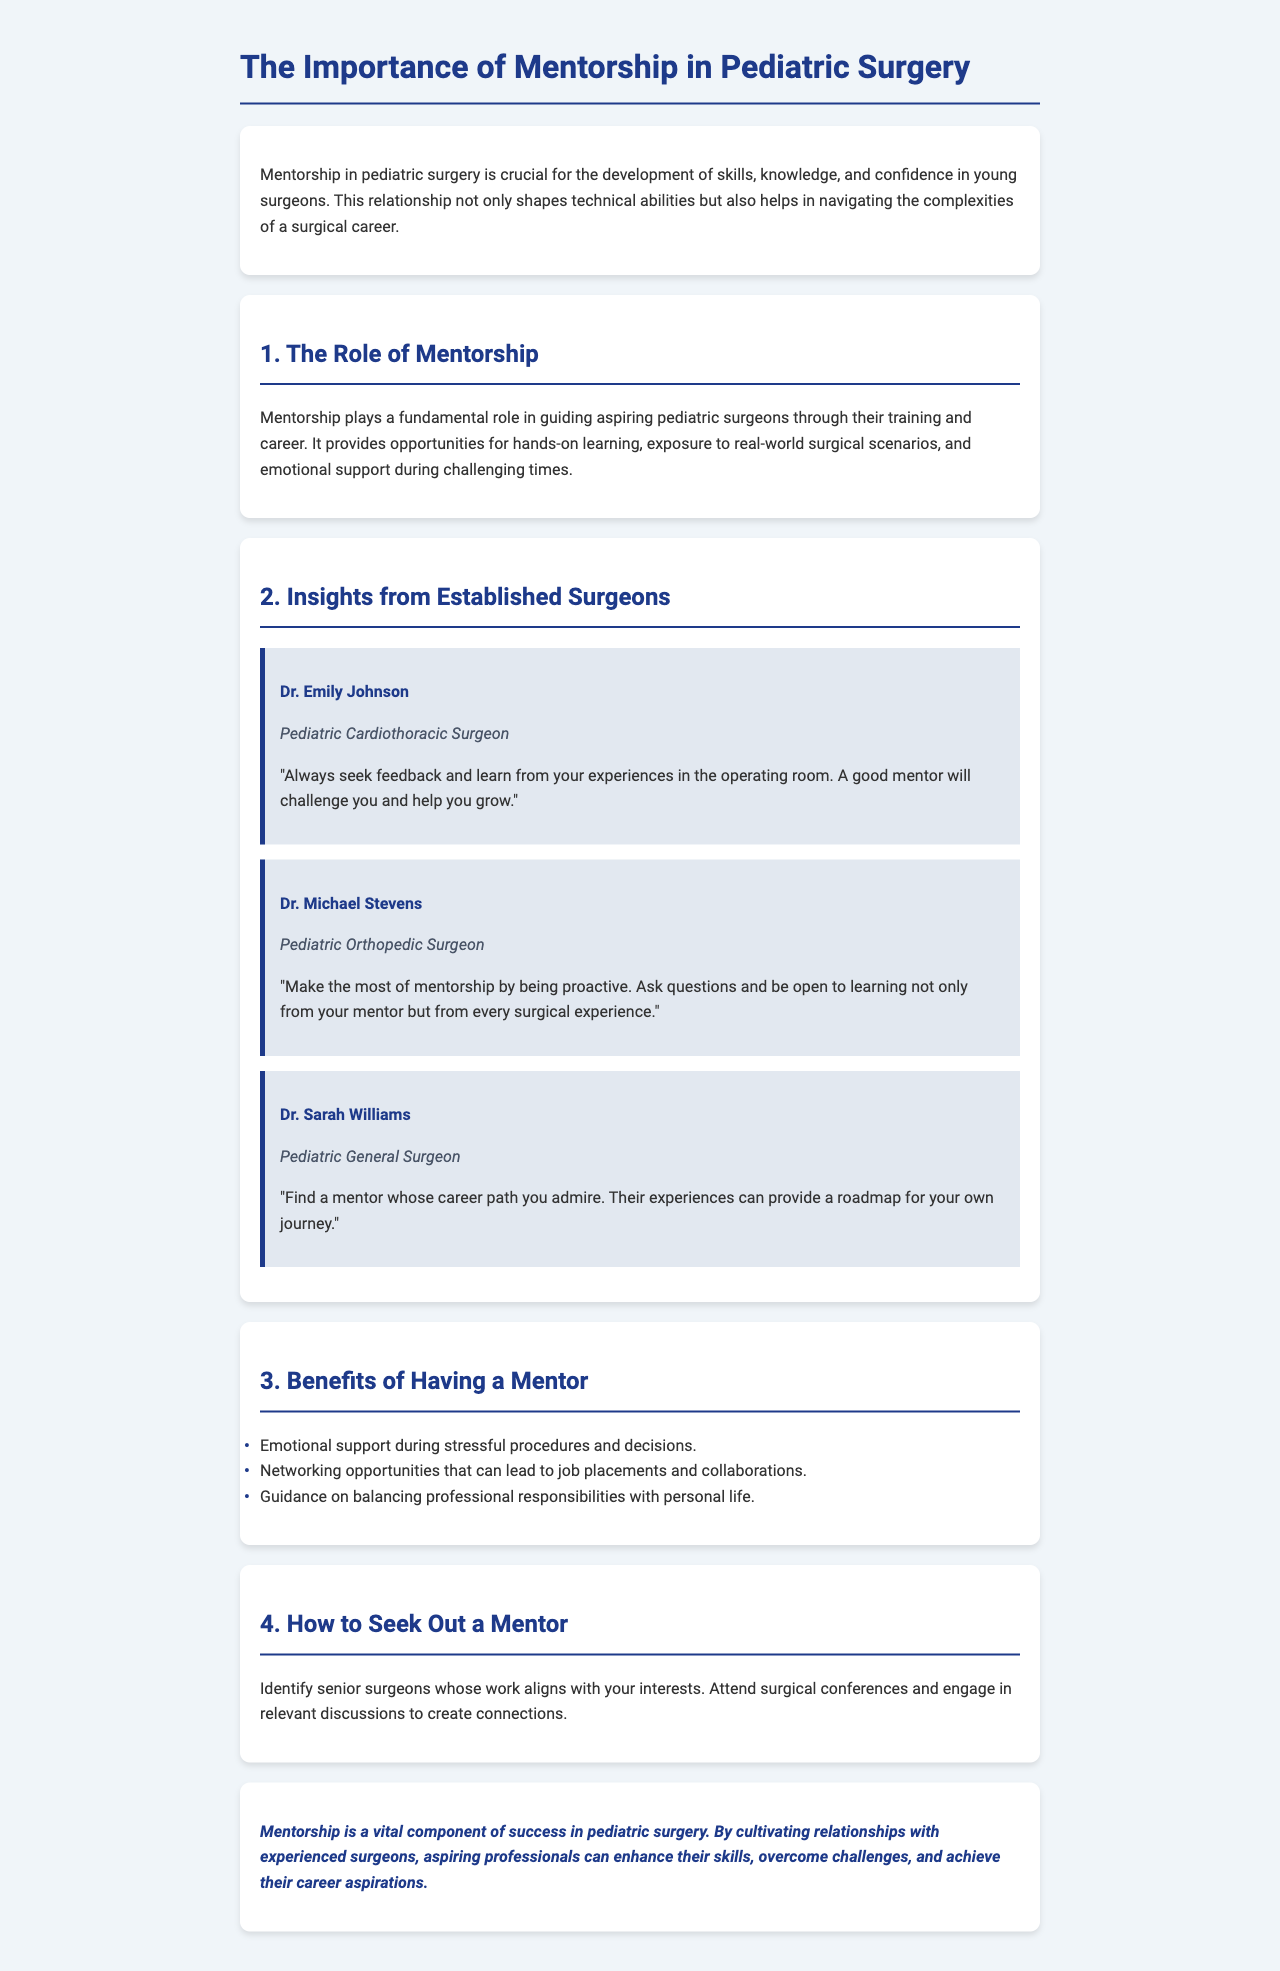What is the title of the report? The title is found in the header section of the document.
Answer: The Importance of Mentorship in Pediatric Surgery Who is a Pediatric Cardiothoracic Surgeon mentioned in the document? This information can be retrieved from the section that discusses insights from established surgeons.
Answer: Dr. Emily Johnson What is one benefit of having a mentor listed in the document? The document lists various benefits in the section covering benefits of having a mentor.
Answer: Emotional support during stressful procedures and decisions What is Dr. Michael Stevens' advice for aspiring pediatric surgeons? This can be found in Dr. Michael Stevens’ advice block in the insights section.
Answer: Be proactive and ask questions How can aspiring surgeons seek out a mentor? The document outlines steps for seeking out a mentor in the respective section.
Answer: Identify senior surgeons whose work aligns with your interests What is the primary focus of the mentorship discussed in the report? The report provides a clear theme in its introduction regarding mentorship's role in pediatric surgery.
Answer: Development of skills, knowledge, and confidence 